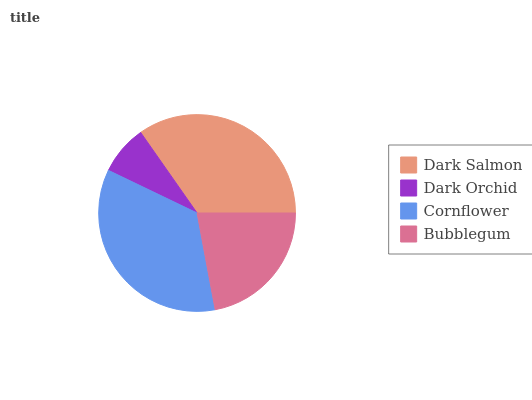Is Dark Orchid the minimum?
Answer yes or no. Yes. Is Cornflower the maximum?
Answer yes or no. Yes. Is Cornflower the minimum?
Answer yes or no. No. Is Dark Orchid the maximum?
Answer yes or no. No. Is Cornflower greater than Dark Orchid?
Answer yes or no. Yes. Is Dark Orchid less than Cornflower?
Answer yes or no. Yes. Is Dark Orchid greater than Cornflower?
Answer yes or no. No. Is Cornflower less than Dark Orchid?
Answer yes or no. No. Is Dark Salmon the high median?
Answer yes or no. Yes. Is Bubblegum the low median?
Answer yes or no. Yes. Is Cornflower the high median?
Answer yes or no. No. Is Dark Salmon the low median?
Answer yes or no. No. 